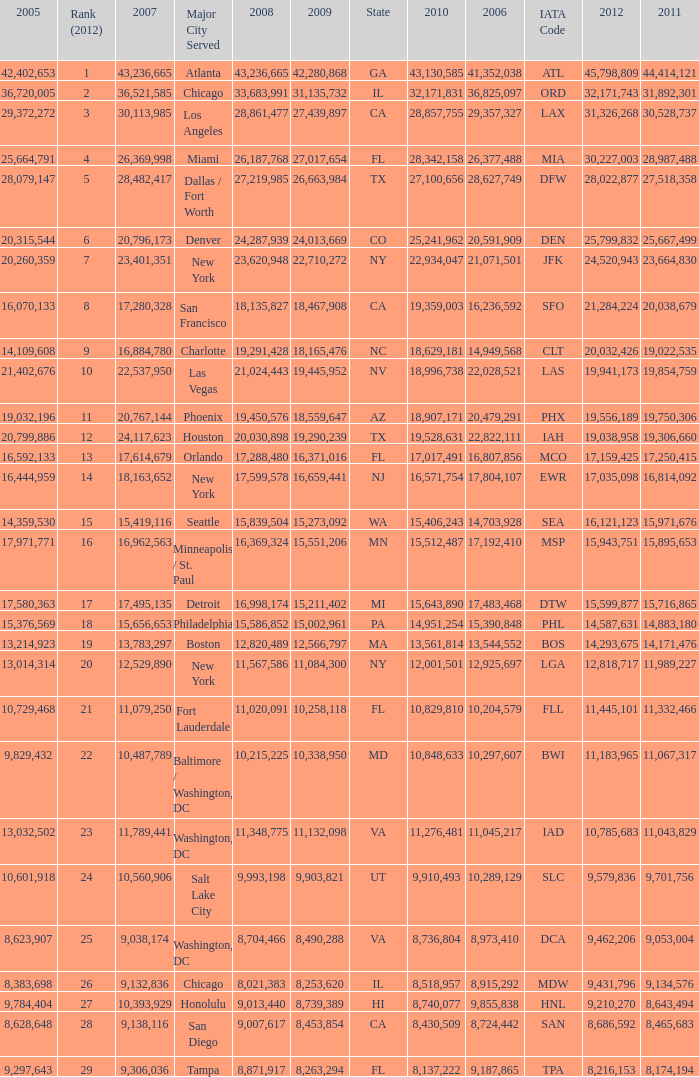When Philadelphia has a 2007 less than 20,796,173 and a 2008 more than 10,215,225, what is the smallest 2009? 15002961.0. 